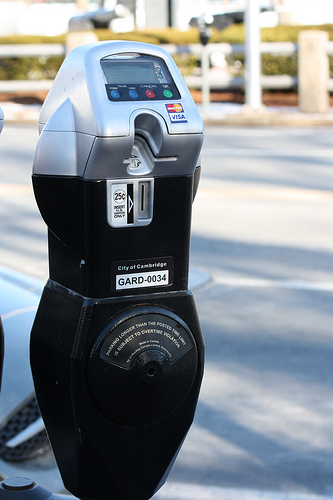What are the payment options available on this parking meter? This parking meter accepts multiple forms of payment including quarters through the coin slot, credit cards through a dedicated card slot clearly marked for Visa among others, and possibly digital payments according to the interface design. 